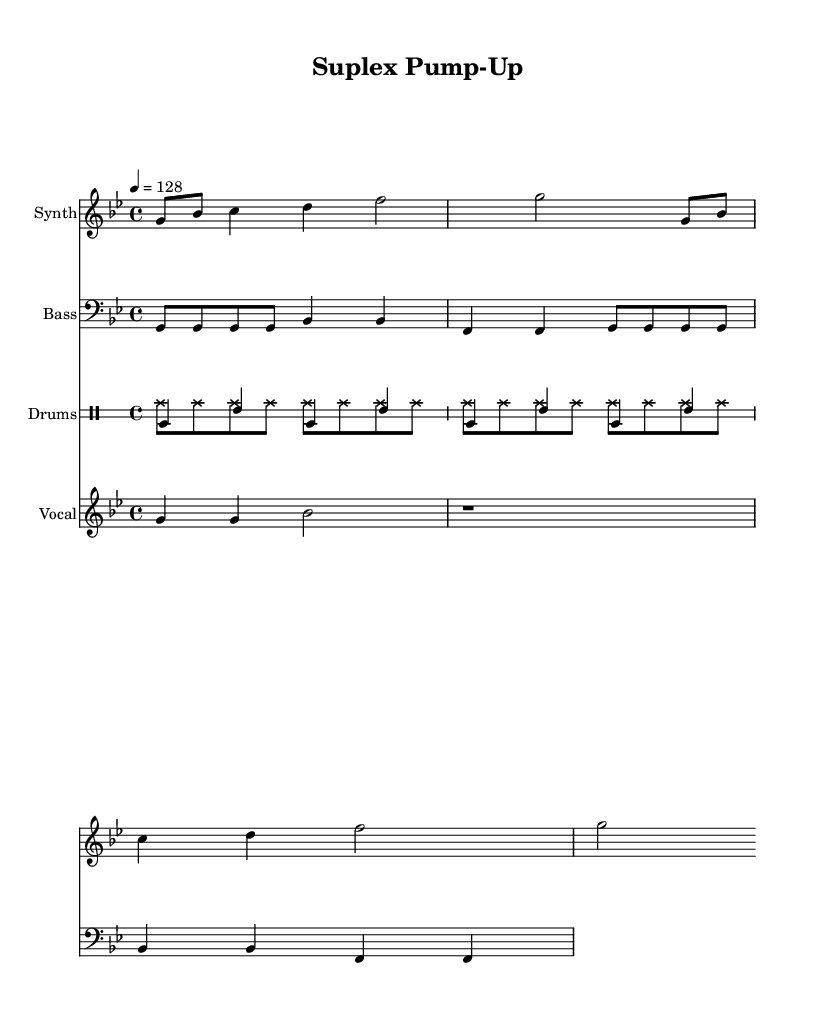What is the key signature of this music? The key signature is G minor, which is indicated by two flats (B flat and E flat). This is derived from both the key signature at the beginning of the staff and the characteristic notes used throughout the piece.
Answer: G minor What is the time signature of this music? The time signature is 4/4, indicated at the beginning of the score. This means there are four beats in each measure, and each quarter note receives one beat.
Answer: 4/4 What is the tempo marking for this music? The tempo marking is 128 beats per minute, which is indicated by '4 = 128'. This means the quarter note is valued at 128 beats per minute, providing a fast-paced driving rhythm typical for motivational house music.
Answer: 128 How many measures are shown in the synth part? The synth part is composed of four measures as indicated by the grouping of notes and the consistent bar lines that separate each measure. Counting these gives a total of four.
Answer: 4 What is the rhythmic pattern used in the bass part? The bass part follows a repeating rhythmic pattern of four eighth notes followed by two quarter notes, consistent throughout the part, signaling steady movement typical in house music.
Answer: Four eighths, two quarter notes What types of drums are used in this piece? The piece features kick drum (bd for bass drum), snare (sn), and hi-hat (hh) sounds. These are common in house music, providing a solid foundation and rhythmic energy for workouts.
Answer: Kick, snare, hi-hat Who is the performer as indicated in the vocal section? The performer indicated in the vocal section is "SuplexMasterJay," as derived from the lyrics provided beneath the vocal notes. This adds an exciting personal touch for the audience.
Answer: SuplexMasterJay 